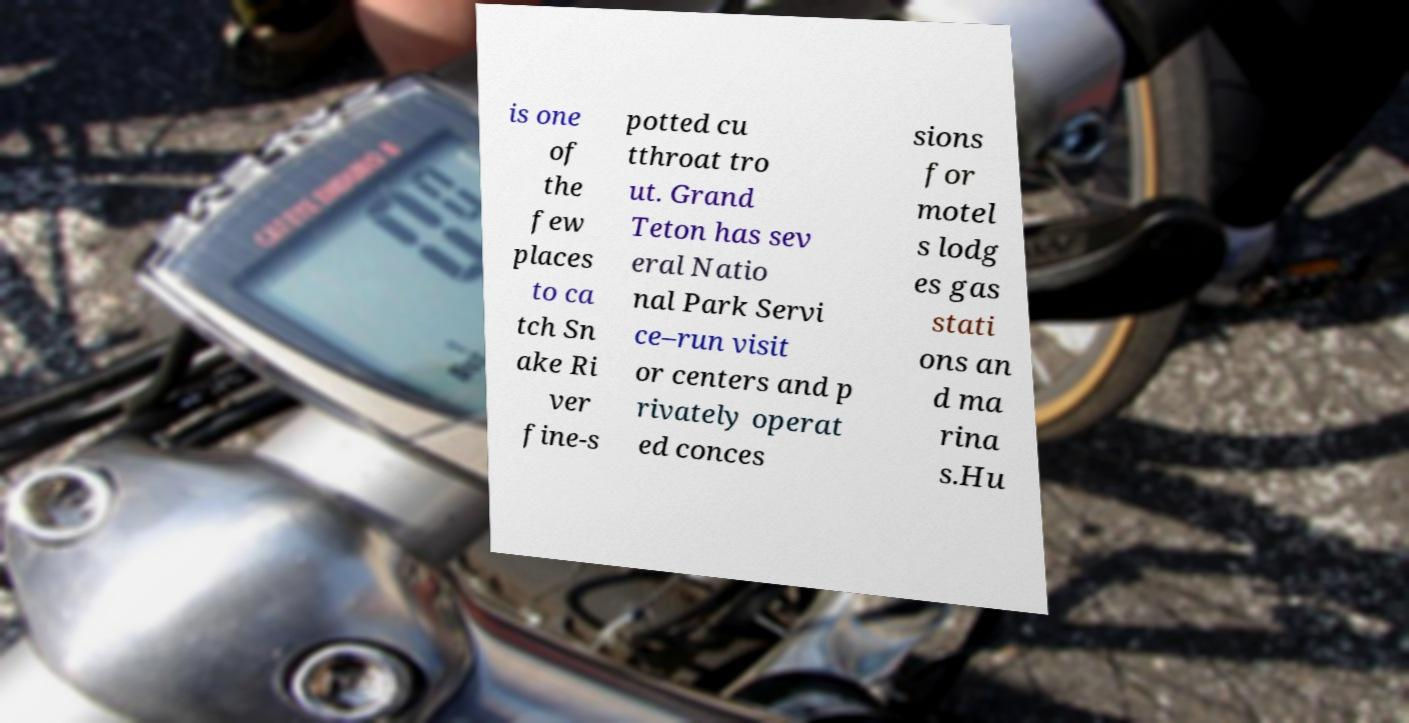For documentation purposes, I need the text within this image transcribed. Could you provide that? is one of the few places to ca tch Sn ake Ri ver fine-s potted cu tthroat tro ut. Grand Teton has sev eral Natio nal Park Servi ce–run visit or centers and p rivately operat ed conces sions for motel s lodg es gas stati ons an d ma rina s.Hu 